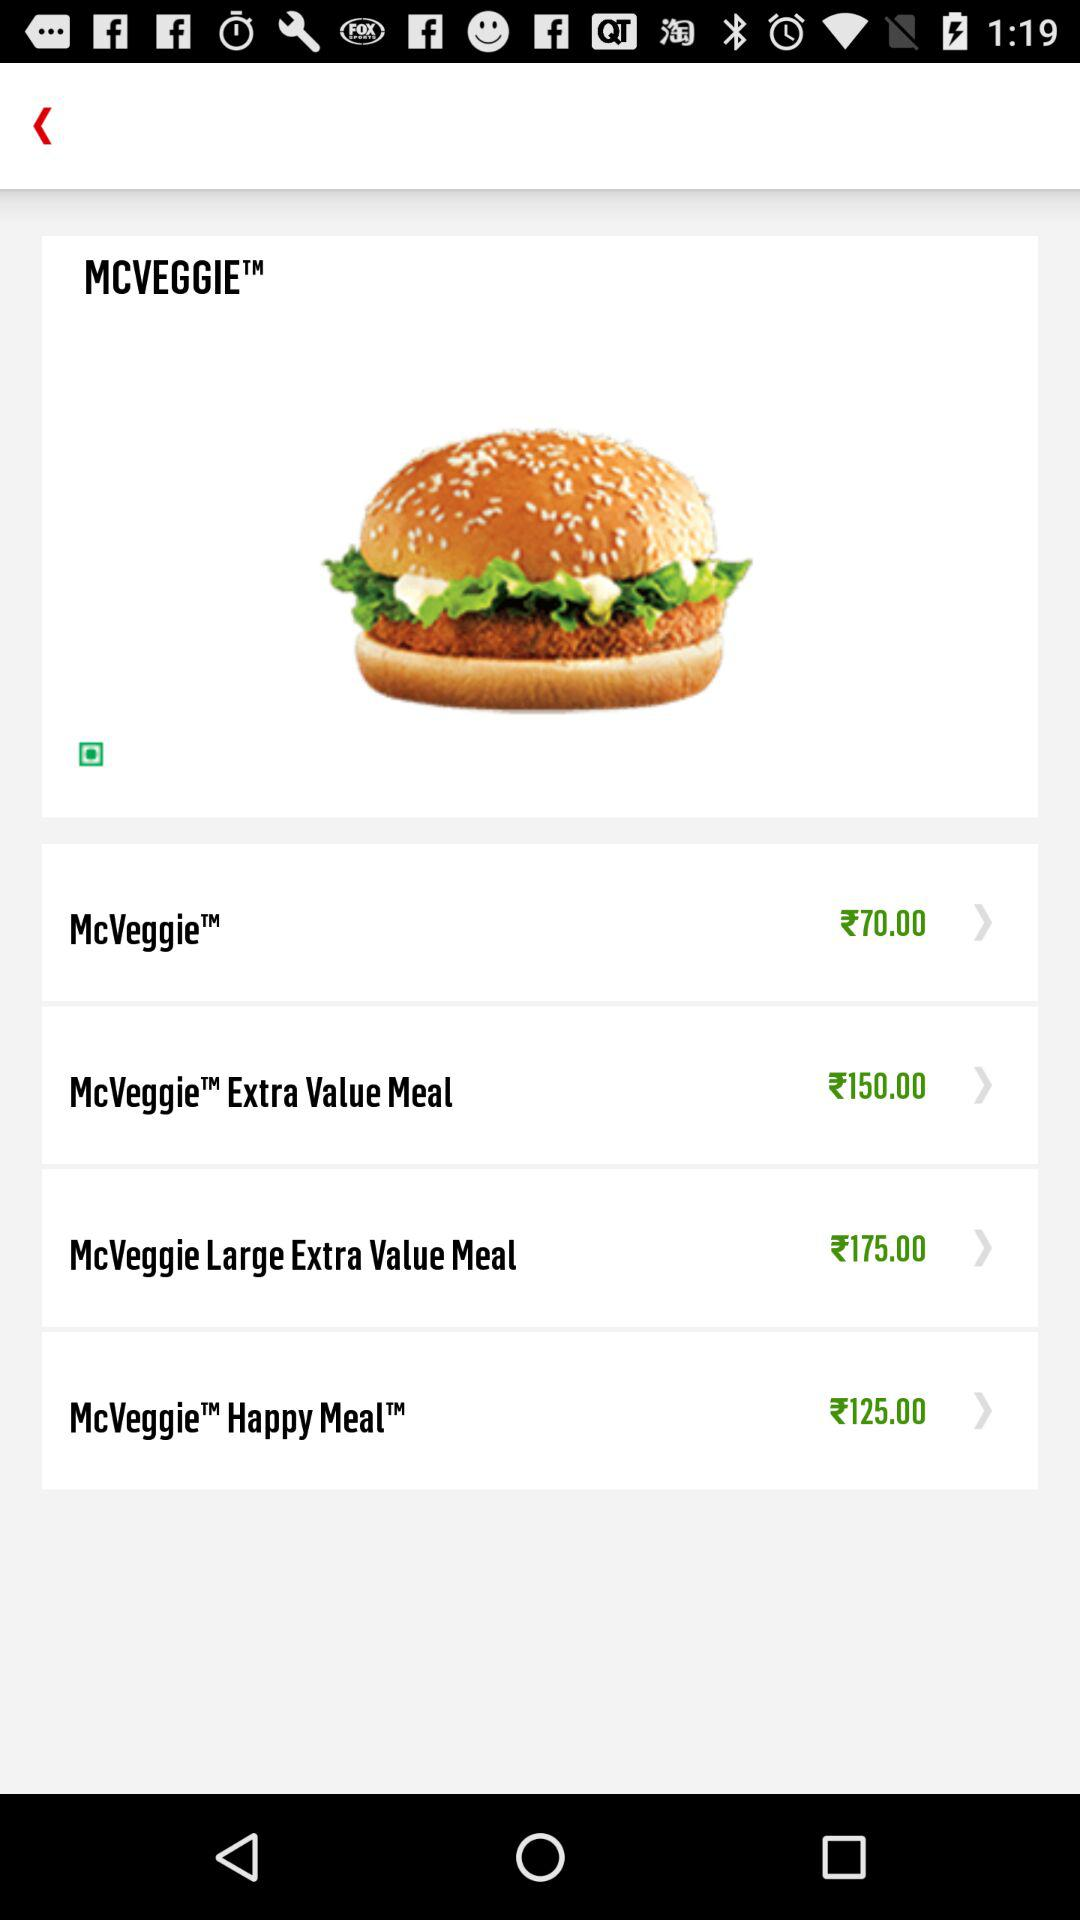What is the price of the "McVeggie Happy Meal"? The price of the "McVeggie Happy Meal" is ₹125. 